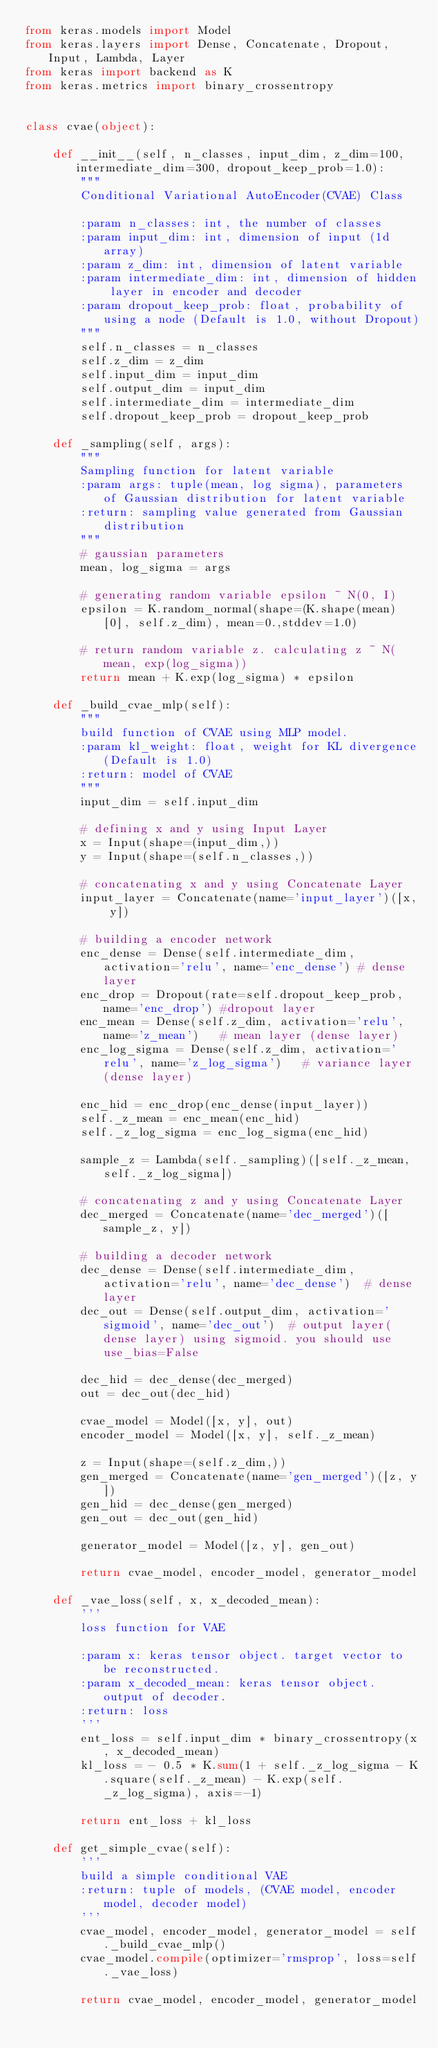<code> <loc_0><loc_0><loc_500><loc_500><_Python_>from keras.models import Model
from keras.layers import Dense, Concatenate, Dropout, Input, Lambda, Layer
from keras import backend as K
from keras.metrics import binary_crossentropy


class cvae(object):

    def __init__(self, n_classes, input_dim, z_dim=100, intermediate_dim=300, dropout_keep_prob=1.0):
        """
        Conditional Variational AutoEncoder(CVAE) Class

        :param n_classes: int, the number of classes
        :param input_dim: int, dimension of input (1d array)
        :param z_dim: int, dimension of latent variable
        :param intermediate_dim: int, dimension of hidden layer in encoder and decoder
        :param dropout_keep_prob: float, probability of using a node (Default is 1.0, without Dropout)
        """
        self.n_classes = n_classes
        self.z_dim = z_dim
        self.input_dim = input_dim
        self.output_dim = input_dim
        self.intermediate_dim = intermediate_dim
        self.dropout_keep_prob = dropout_keep_prob

    def _sampling(self, args):
        """
        Sampling function for latent variable
        :param args: tuple(mean, log sigma), parameters of Gaussian distribution for latent variable
        :return: sampling value generated from Gaussian distribution
        """
        # gaussian parameters
        mean, log_sigma = args

        # generating random variable epsilon ~ N(0, I)
        epsilon = K.random_normal(shape=(K.shape(mean)[0], self.z_dim), mean=0.,stddev=1.0)

        # return random variable z. calculating z ~ N(mean, exp(log_sigma))
        return mean + K.exp(log_sigma) * epsilon

    def _build_cvae_mlp(self):
        """
        build function of CVAE using MLP model.
        :param kl_weight: float, weight for KL divergence(Default is 1.0)
        :return: model of CVAE
        """
        input_dim = self.input_dim

        # defining x and y using Input Layer
        x = Input(shape=(input_dim,))
        y = Input(shape=(self.n_classes,))

        # concatenating x and y using Concatenate Layer
        input_layer = Concatenate(name='input_layer')([x, y])

        # building a encoder network
        enc_dense = Dense(self.intermediate_dim, activation='relu', name='enc_dense') # dense layer
        enc_drop = Dropout(rate=self.dropout_keep_prob, name='enc_drop') #dropout layer
        enc_mean = Dense(self.z_dim, activation='relu', name='z_mean')   # mean layer (dense layer)
        enc_log_sigma = Dense(self.z_dim, activation='relu', name='z_log_sigma')   # variance layer (dense layer)

        enc_hid = enc_drop(enc_dense(input_layer))
        self._z_mean = enc_mean(enc_hid)
        self._z_log_sigma = enc_log_sigma(enc_hid)

        sample_z = Lambda(self._sampling)([self._z_mean, self._z_log_sigma])

        # concatenating z and y using Concatenate Layer
        dec_merged = Concatenate(name='dec_merged')([sample_z, y])

        # building a decoder network
        dec_dense = Dense(self.intermediate_dim, activation='relu', name='dec_dense')  # dense layer
        dec_out = Dense(self.output_dim, activation='sigmoid', name='dec_out')  # output layer(dense layer) using sigmoid. you should use use_bias=False

        dec_hid = dec_dense(dec_merged)
        out = dec_out(dec_hid)

        cvae_model = Model([x, y], out)
        encoder_model = Model([x, y], self._z_mean)

        z = Input(shape=(self.z_dim,))
        gen_merged = Concatenate(name='gen_merged')([z, y])
        gen_hid = dec_dense(gen_merged)
        gen_out = dec_out(gen_hid)

        generator_model = Model([z, y], gen_out)

        return cvae_model, encoder_model, generator_model

    def _vae_loss(self, x, x_decoded_mean):
        '''
        loss function for VAE

        :param x: keras tensor object. target vector to be reconstructed.
        :param x_decoded_mean: keras tensor object. output of decoder.
        :return: loss
        '''
        ent_loss = self.input_dim * binary_crossentropy(x, x_decoded_mean)
        kl_loss = - 0.5 * K.sum(1 + self._z_log_sigma - K.square(self._z_mean) - K.exp(self._z_log_sigma), axis=-1)

        return ent_loss + kl_loss

    def get_simple_cvae(self):
        '''
        build a simple conditional VAE
        :return: tuple of models, (CVAE model, encoder model, decoder model)
        '''
        cvae_model, encoder_model, generator_model = self._build_cvae_mlp()
        cvae_model.compile(optimizer='rmsprop', loss=self._vae_loss)

        return cvae_model, encoder_model, generator_model
</code> 